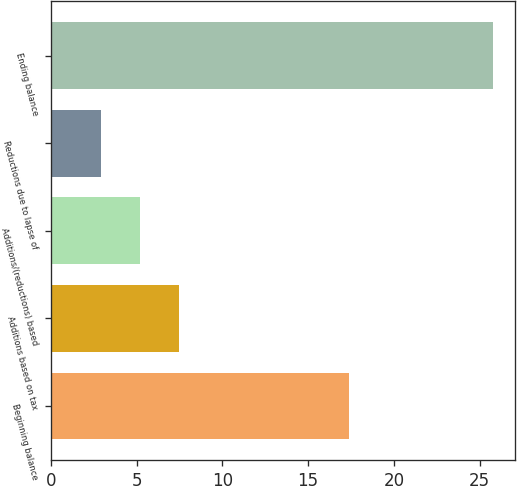Convert chart to OTSL. <chart><loc_0><loc_0><loc_500><loc_500><bar_chart><fcel>Beginning balance<fcel>Additions based on tax<fcel>Additions/(reductions) based<fcel>Reductions due to lapse of<fcel>Ending balance<nl><fcel>17.4<fcel>7.48<fcel>5.19<fcel>2.9<fcel>25.8<nl></chart> 